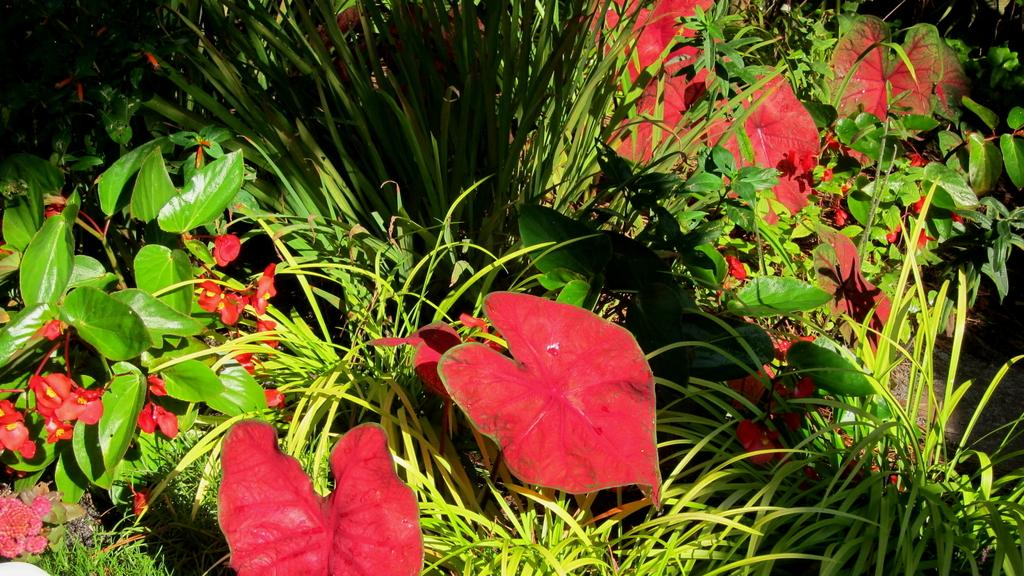What type of vegetation is present in the image? There are grass plants in the image. What else can be seen in the image besides grass plants? There are leaves in the image. What town is responsible for the achievements of the person in the image? There is no person or town present in the image; it only features grass plants and leaves. 